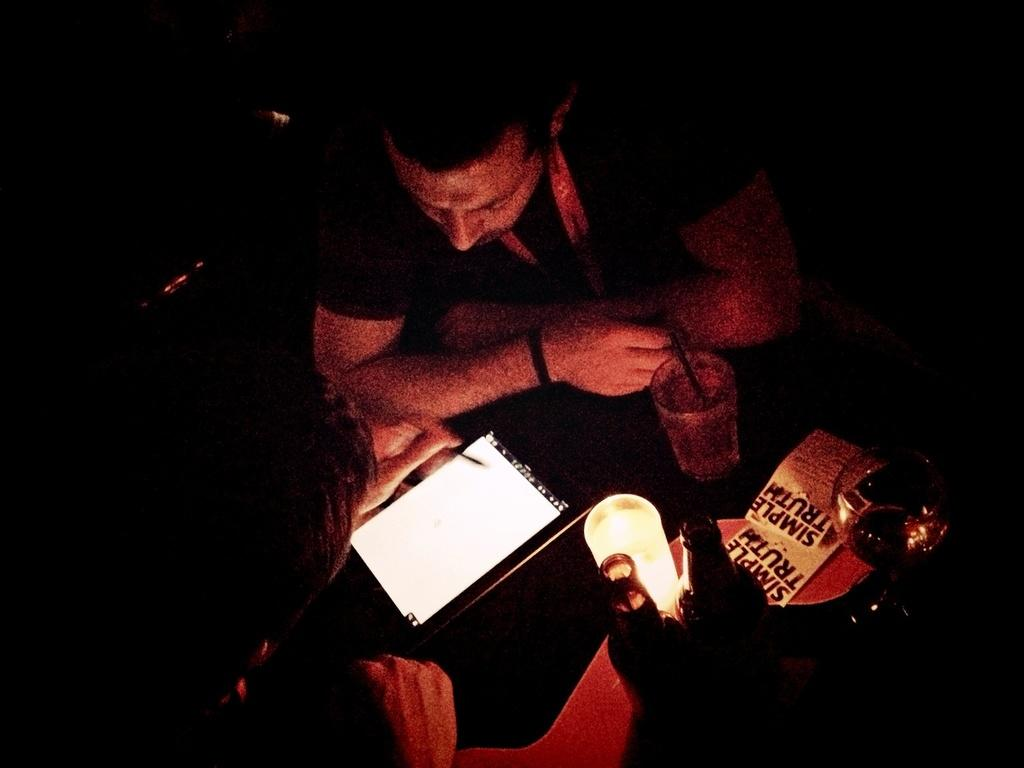How many people are in the image? There are two men in the image. What are the men looking at? The men are looking at an i-pod. What can be seen on the right side of the image? There are wine bottles and wine glasses on the right side of the image. What advice are the men giving to the protestors in the image? There are no protestors present in the image, and the men are not giving any advice. 